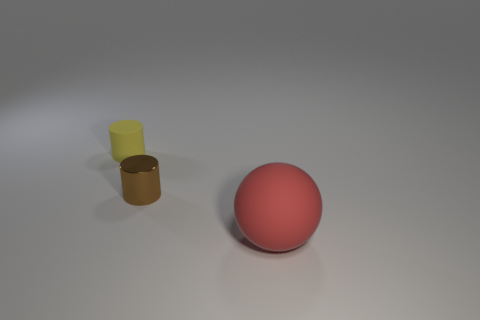What is the color of the matte object that is to the left of the rubber thing in front of the yellow matte thing? In the image provided, there appears to be a red matte sphere to the left of a glossy gold-colored cylinder and in front of a yellow matte cylinder. Therefore, the color of the matte object you're asking about is red. 